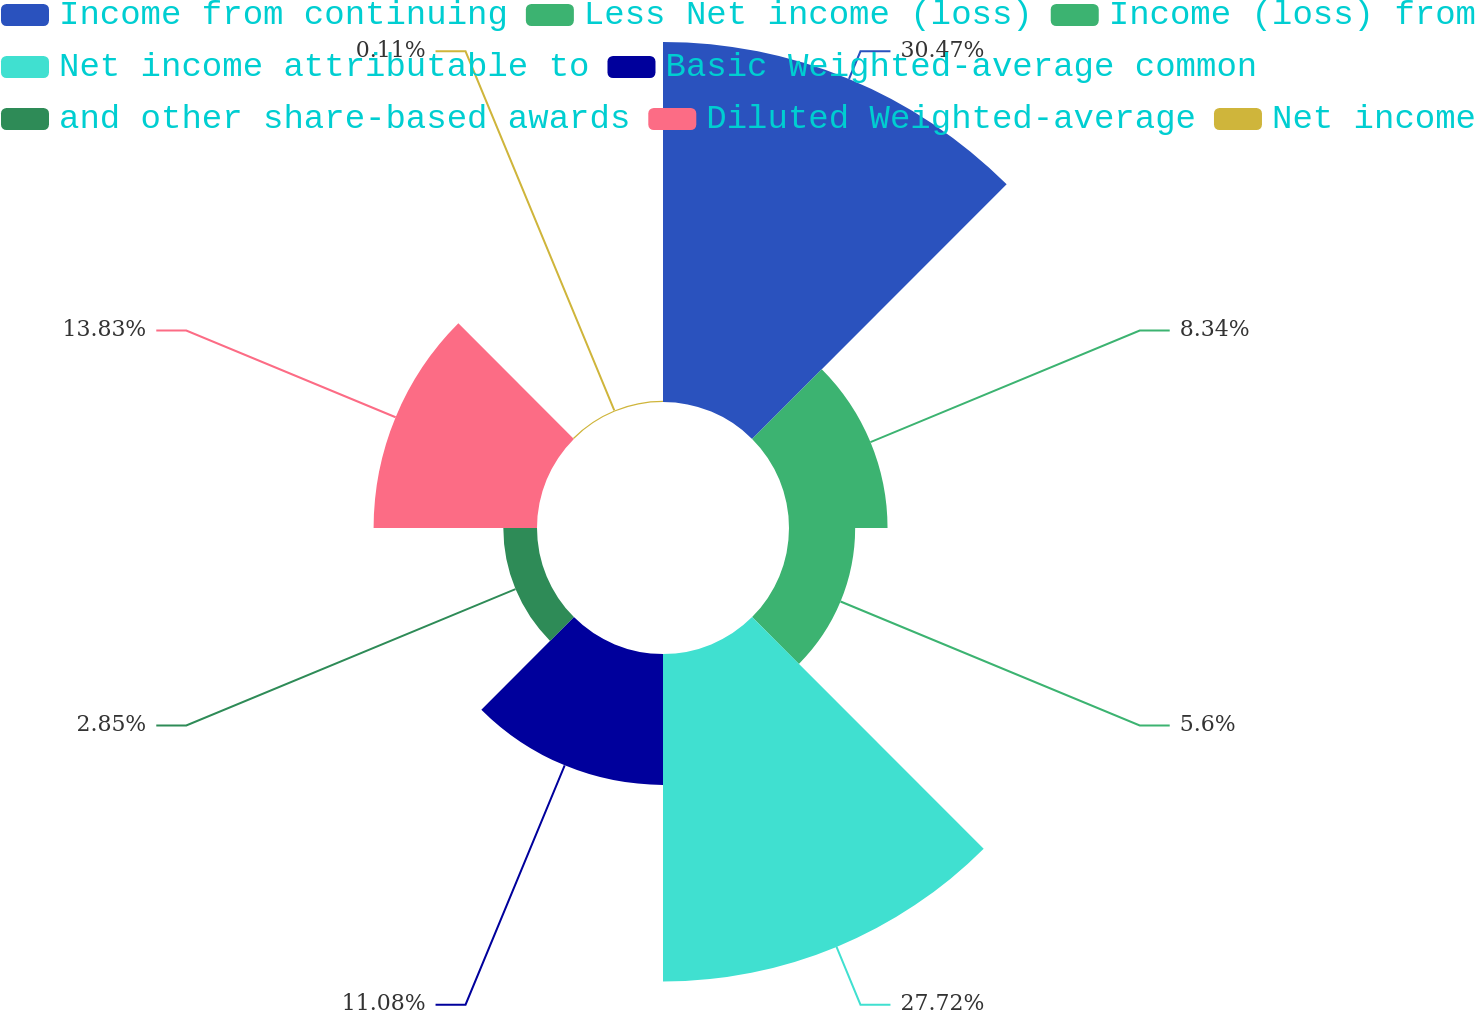<chart> <loc_0><loc_0><loc_500><loc_500><pie_chart><fcel>Income from continuing<fcel>Less Net income (loss)<fcel>Income (loss) from<fcel>Net income attributable to<fcel>Basic Weighted-average common<fcel>and other share-based awards<fcel>Diluted Weighted-average<fcel>Net income<nl><fcel>30.47%<fcel>8.34%<fcel>5.6%<fcel>27.72%<fcel>11.08%<fcel>2.85%<fcel>13.83%<fcel>0.11%<nl></chart> 